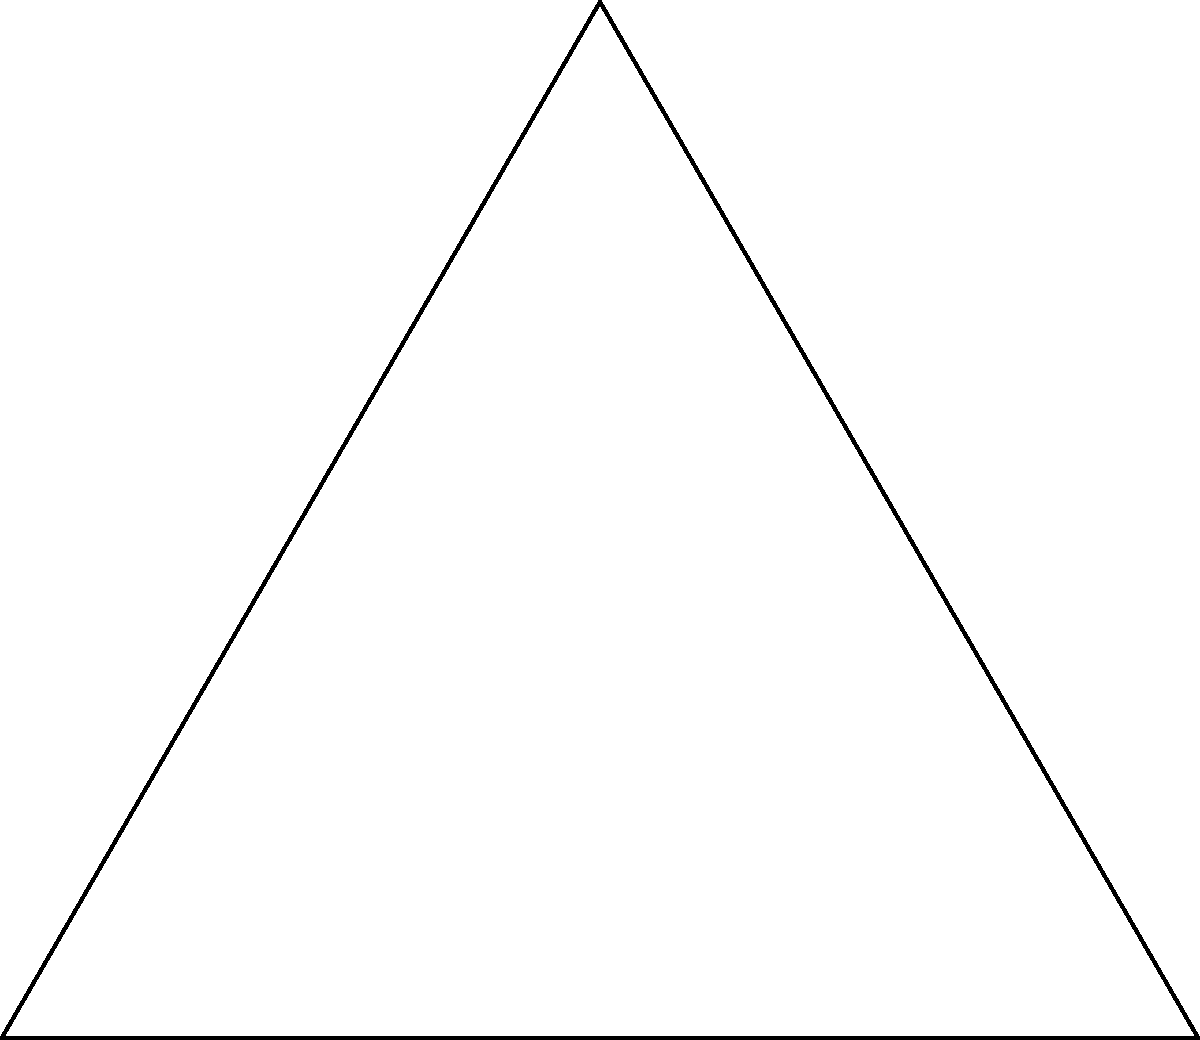In a shoulder rotation exercise for injury prevention, a dog's shoulder joint rotates through an arc of 60°. If the length of the dog's upper arm (humerus) is 15 cm, what is the range of motion (in cm) for this exercise? Use the arc length formula to calculate your answer. To solve this problem, we'll use the arc length formula from trigonometry:

Arc Length = $r \theta$

Where:
$r$ = radius (length of the upper arm)
$\theta$ = angle in radians

Step 1: Convert the angle from degrees to radians
60° = $\frac{60 \pi}{180}$ = $\frac{\pi}{3}$ radians

Step 2: Apply the arc length formula
Arc Length = $r \theta$
           = $15 \cdot \frac{\pi}{3}$
           = $5\pi$ cm

Step 3: Calculate the final result
Arc Length = $5\pi$ ≈ 15.71 cm

The range of motion for this shoulder rotation exercise is approximately 15.71 cm.
Answer: $5\pi$ cm (≈ 15.71 cm) 